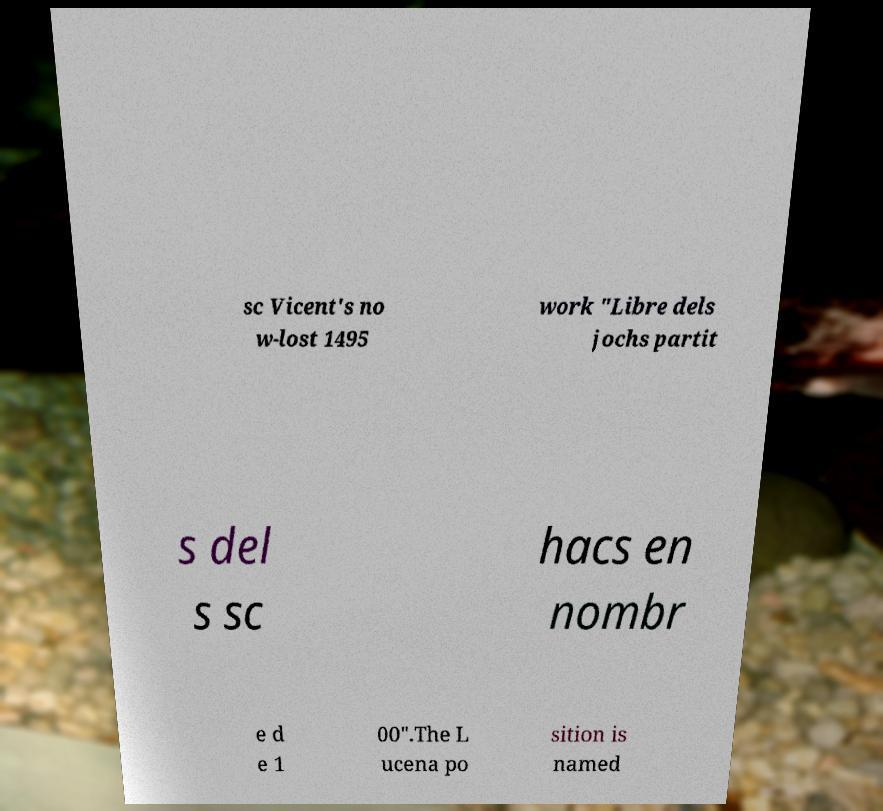Could you assist in decoding the text presented in this image and type it out clearly? sc Vicent's no w-lost 1495 work "Libre dels jochs partit s del s sc hacs en nombr e d e 1 00".The L ucena po sition is named 